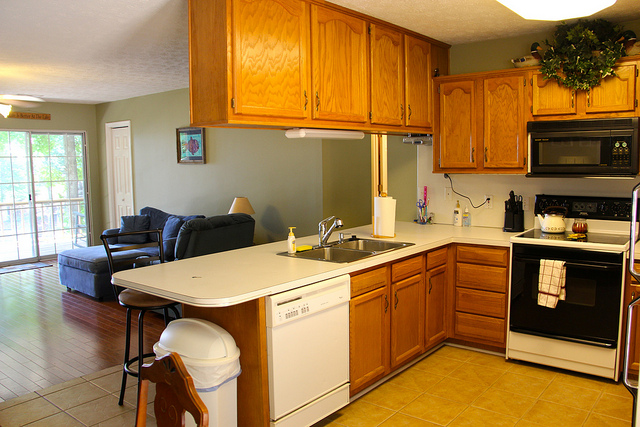<image>Is there any food inside the stove? It is unknown if there is any food inside the stove. Is there any food inside the stove? There is no food inside the stove. 